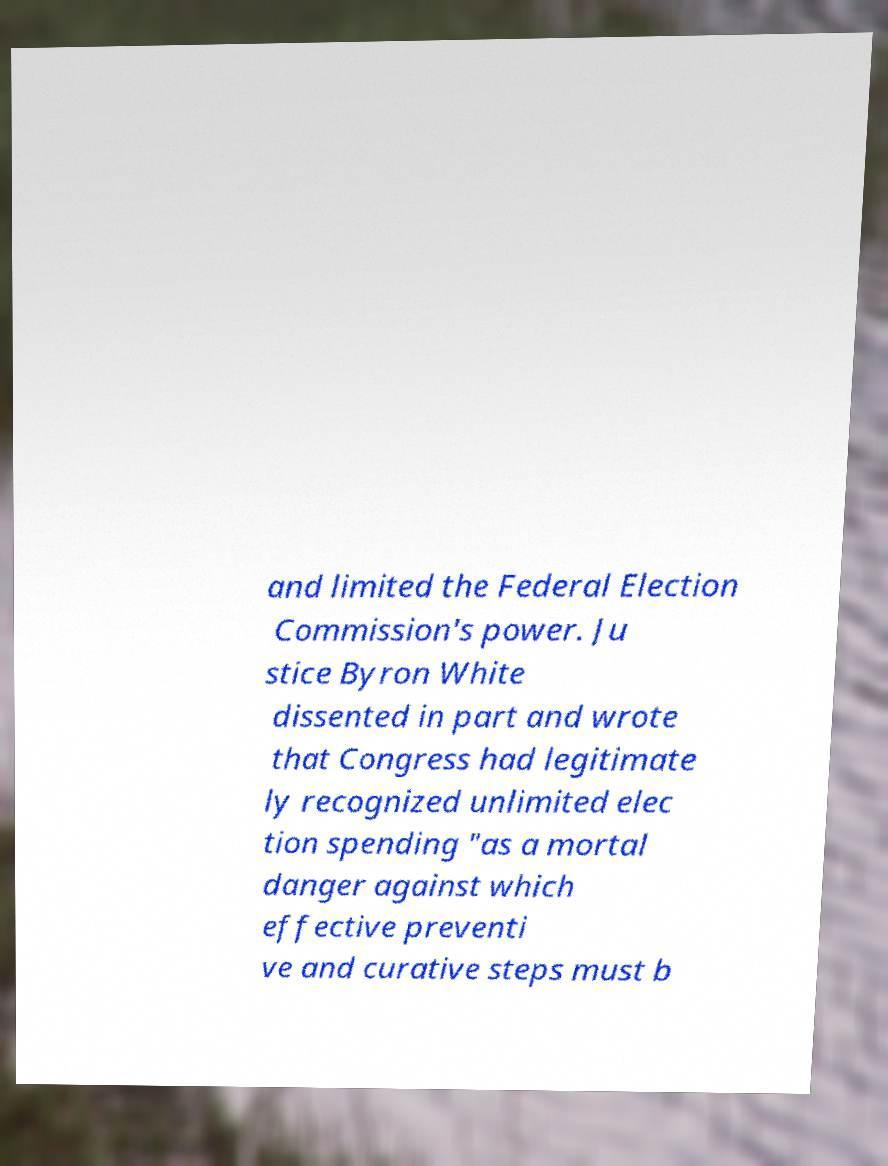Please identify and transcribe the text found in this image. and limited the Federal Election Commission's power. Ju stice Byron White dissented in part and wrote that Congress had legitimate ly recognized unlimited elec tion spending "as a mortal danger against which effective preventi ve and curative steps must b 